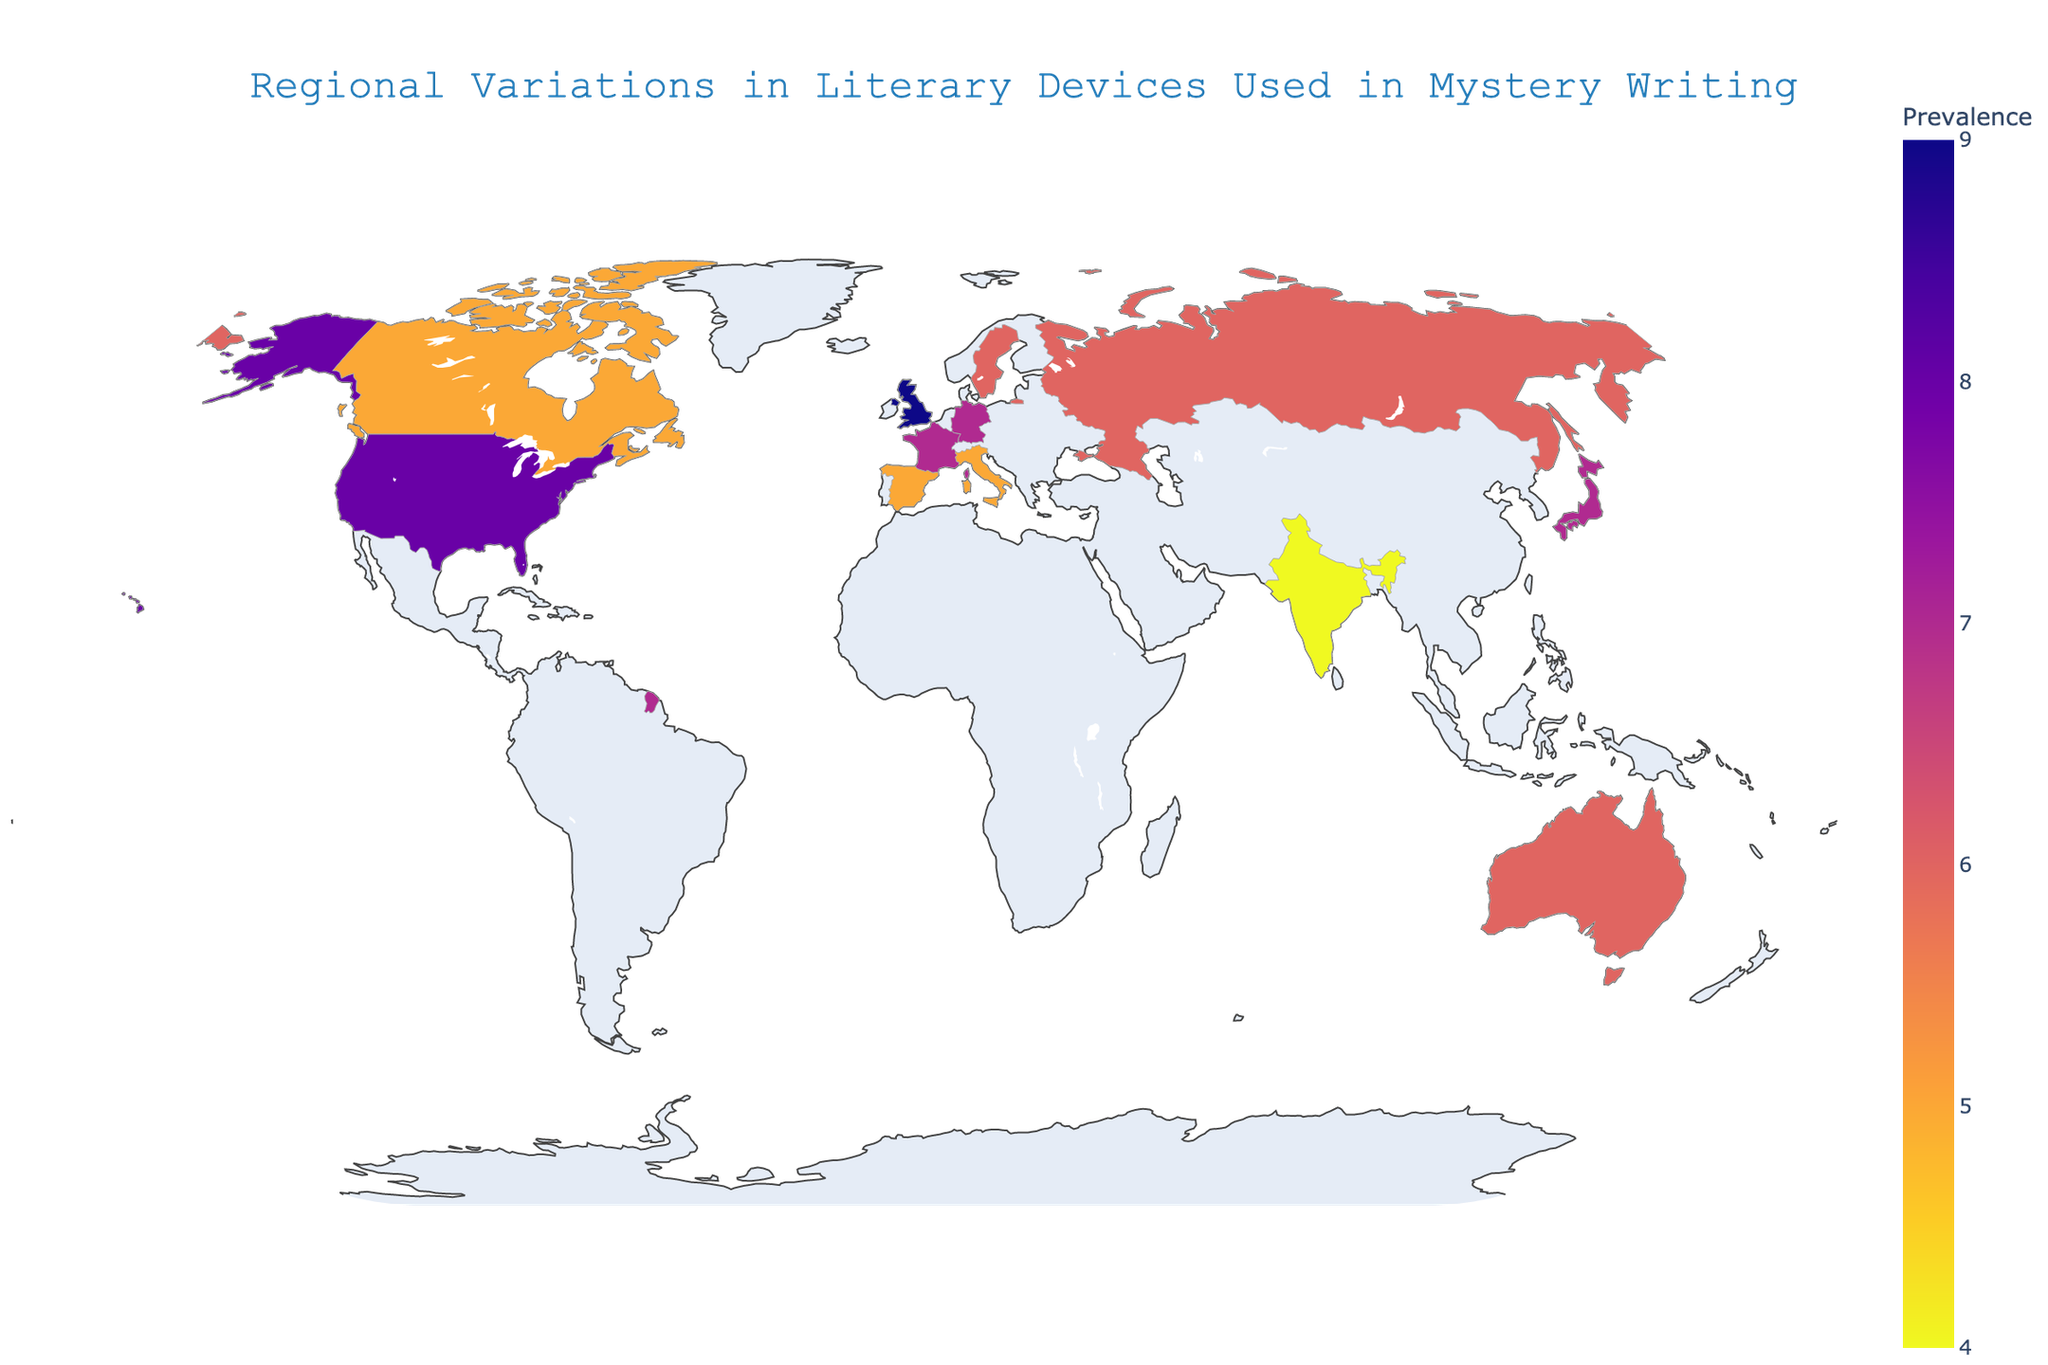What's the prevalence score of France? The prevalence score is indicated by the color intensity on the map. By hovering over France, we can see its prevalence score is displayed as a tooltip.
Answer: 7 Which country uses "Plot Twist" as a primary literary device? By identifying the country on the map with the text "Plot Twist" displayed in the tooltip when hovered over, we find that Germany uses "Plot Twist" as a primary literary device.
Answer: Germany How many countries have a prevalence score higher than 6? By hovering over each country and observing the prevalence scores, we find that the United States, United Kingdom, Japan, France, and Germany have prevalence scores higher than 6. That makes a total of 5 countries.
Answer: 5 Compare the prevalence scores of Australia and Canada. Which one is higher? The prevalence score for Australia is 6 and for Canada is 5. Therefore, Australia's prevalence score is higher.
Answer: Australia What are the primary and secondary literary devices used in Japan? Hovering over Japan shows the tooltip with "Locked Room Mystery" as the primary device and "Alibi" as the secondary device.
Answer: Locked Room Mystery, Alibi What's the average prevalence score of all countries? First, sum the prevalence scores: 8 + 9 + 7 + 6 + 7 + 5 + 6 + 5 + 7 + 6 + 5 + 4 = 75. There are 12 countries, so the average is 75 / 12 = 6.25.
Answer: 6.25 Which country primarily uses "Dramatic Irony," and what is its prevalence score? Hovering over Canada shows that it uses "Dramatic Irony" as the primary device with a prevalence score of 5.
Answer: Canada, 5 Find two countries that use "Foreshadowing" as either a primary or secondary literary device and compare their prevalence scores. The United Kingdom uses "Foreshadowing" as a primary device with a prevalence score of 9, and Spain uses it as a secondary device with a prevalence score of 5. By comparing them, the United Kingdom has a higher prevalence score.
Answer: United Kingdom, Spain Which region of the world shows the highest prevalence of psychological elements in mystery writing? Hovering over Sweden and Russia, we find that Sweden employs "Psychological Suspense" with a prevalence of 6, while Russia uses "Unreliable Narrator", another psychological element, with the same score. Comparing them to non-psychological elements, none exceed (with the exception of countries already having higher prevalence scores for non-psychological elements). Therefore, Russia and Sweden show an equivalent high prevalence for psychological elements.
Answer: Sweden, Russia 